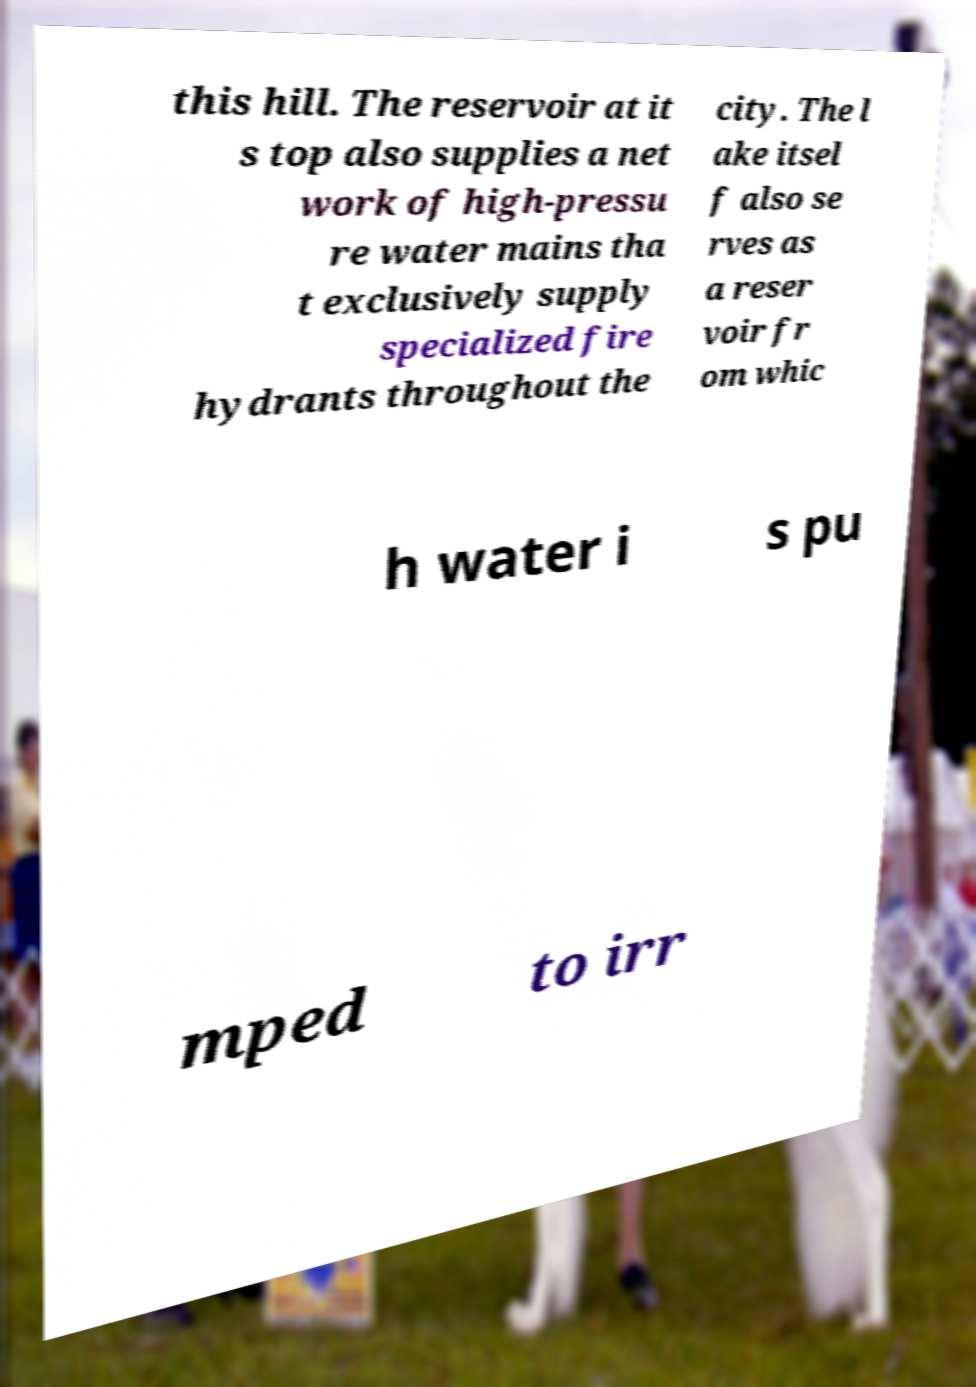Could you extract and type out the text from this image? this hill. The reservoir at it s top also supplies a net work of high-pressu re water mains tha t exclusively supply specialized fire hydrants throughout the city. The l ake itsel f also se rves as a reser voir fr om whic h water i s pu mped to irr 